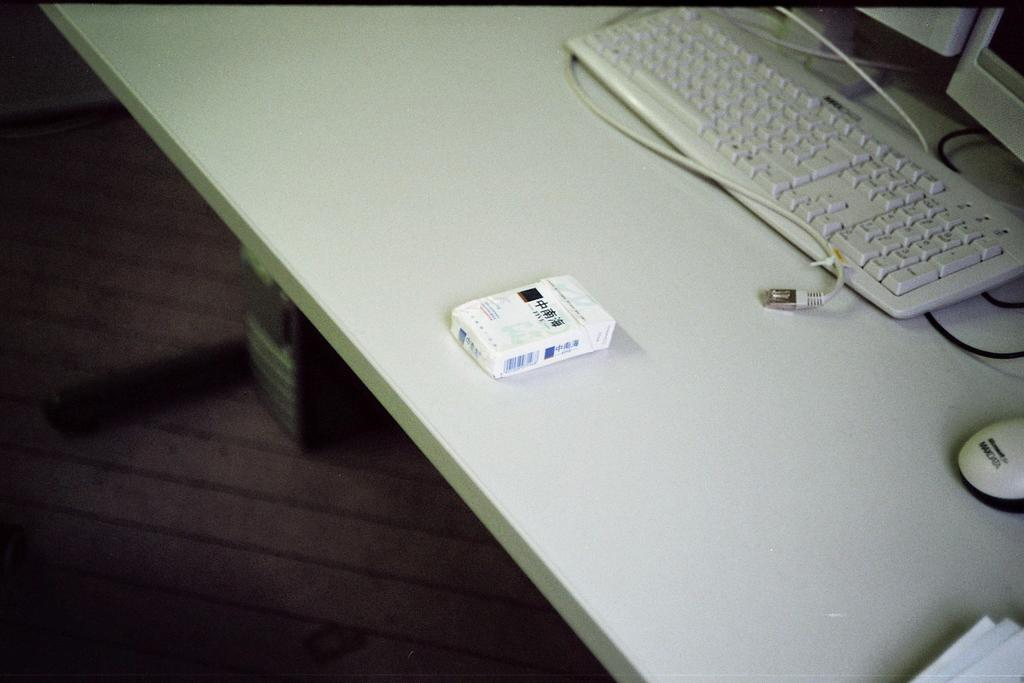<image>
Summarize the visual content of the image. A MAXDATA computer mouse sits next to a white keyboard that isn't plugged in. 